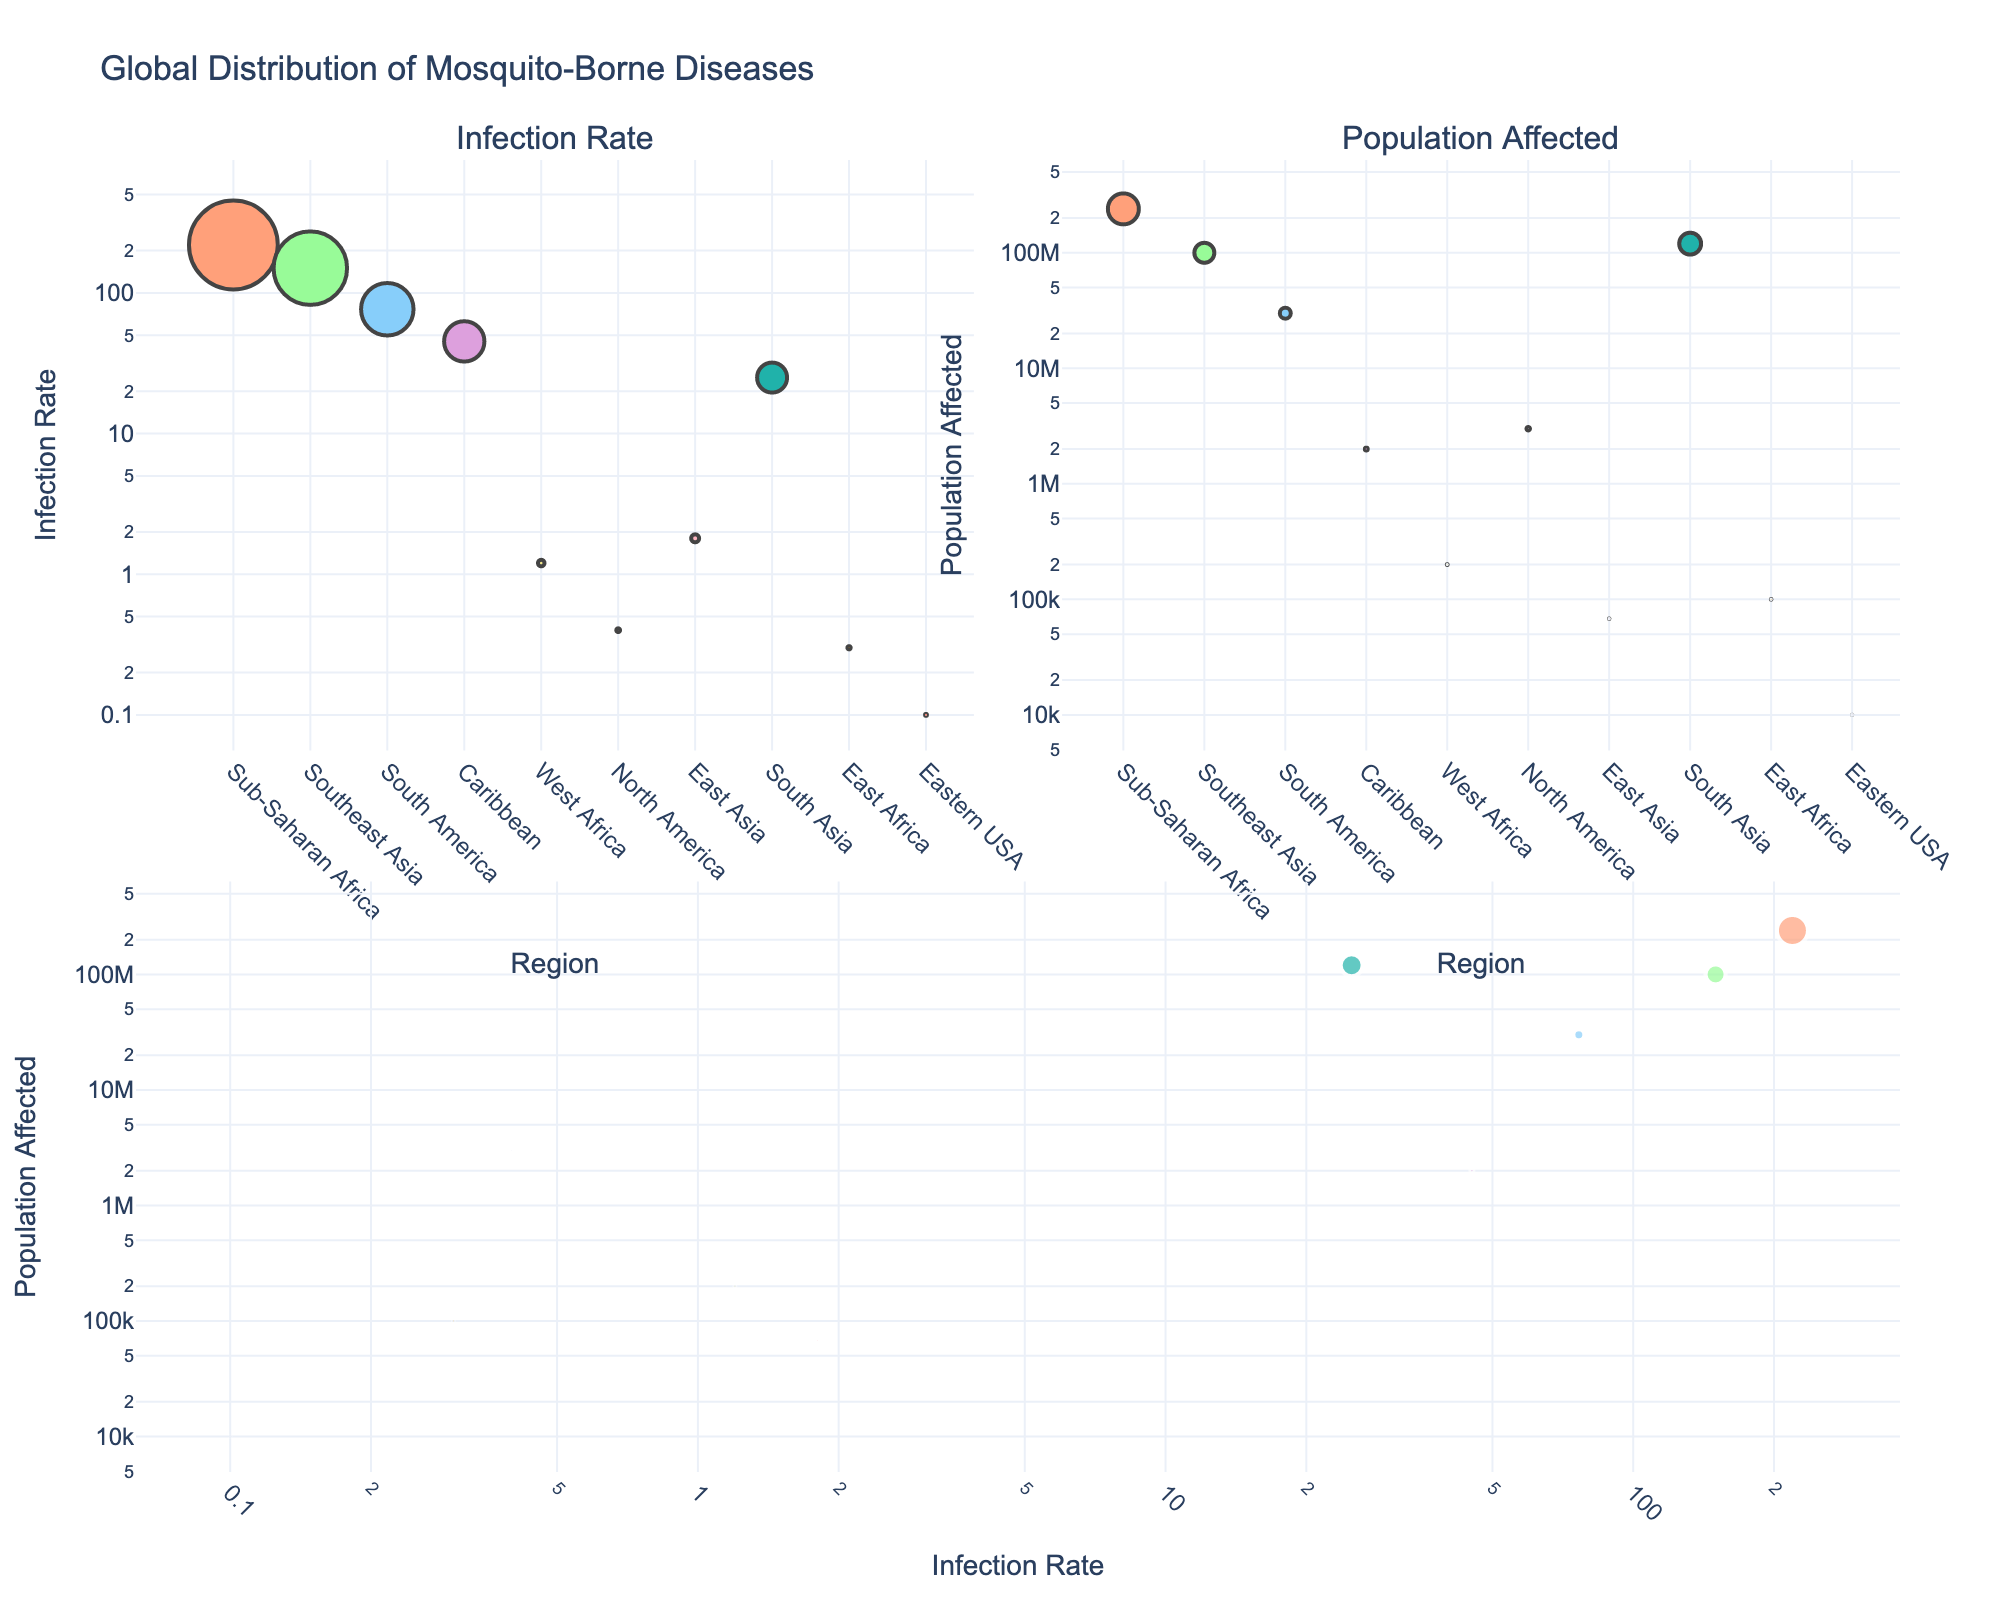What's the title of the figure? Look at the top of the figure where the title is usually placed.
Answer: Global Distribution of Mosquito-Borne Diseases Which disease has the highest infection rate in Sub-Saharan Africa? Check the bubble labeled for Sub-Saharan Africa in the Infection Rate subplot. The bubble for Malaria is the largest with the highest infection rate.
Answer: Malaria What is the smallest infection rate displayed in the figure? Look for the smallest bubble in the Infection Rate subplot. Eastern Equine Encephalitis in Eastern USA has the smallest infection rate.
Answer: 0.1 Which region has the highest population affected by a mosquito-borne disease? Look at the largest bubble in the Population Affected subplot in terms of area. The largest bubble corresponds to Malaria in Sub-Saharan Africa.
Answer: Sub-Saharan Africa What is the average infection rate of Dengue and Zika? Find the infection rates for Dengue and Zika, then calculate the average: (150.0 + 76.5) / 2.
Answer: 113.25 Compare the infection rate of Chikungunya with Yellow Fever. Which has a higher rate, and by how much? Check the infection rates of Chikungunya and Yellow Fever in the Infection Rate subplot. Chikungunya has an infection rate of 45.2, and Yellow Fever has 1.2. The difference is 45.2 - 1.2.
Answer: Chikungunya by 44 Which disease affects the most people in South America? Look at the bubbles in South America in the Population Affected subplot and identify the largest bubble. Zika has the largest bubble in South America.
Answer: Zika How is the population affected by Japanese Encephalitis correlated to its infection rate? Compare the Population Affected and Infection Rate for Japanese Encephalitis in the combined plot. Japanese Encephalitis has a higher population affected than its relatively low infection rate would suggest.
Answer: High population, low infection rate Which disease has a larger bubble size in the combined plot, Lymphatic Filariasis or West Nile Virus? In the combined subplot, look for the bubbles for Lymphatic Filariasis and West Nile Virus. Lymphatic Filariasis has a larger bubble.
Answer: Lymphatic Filariasis 